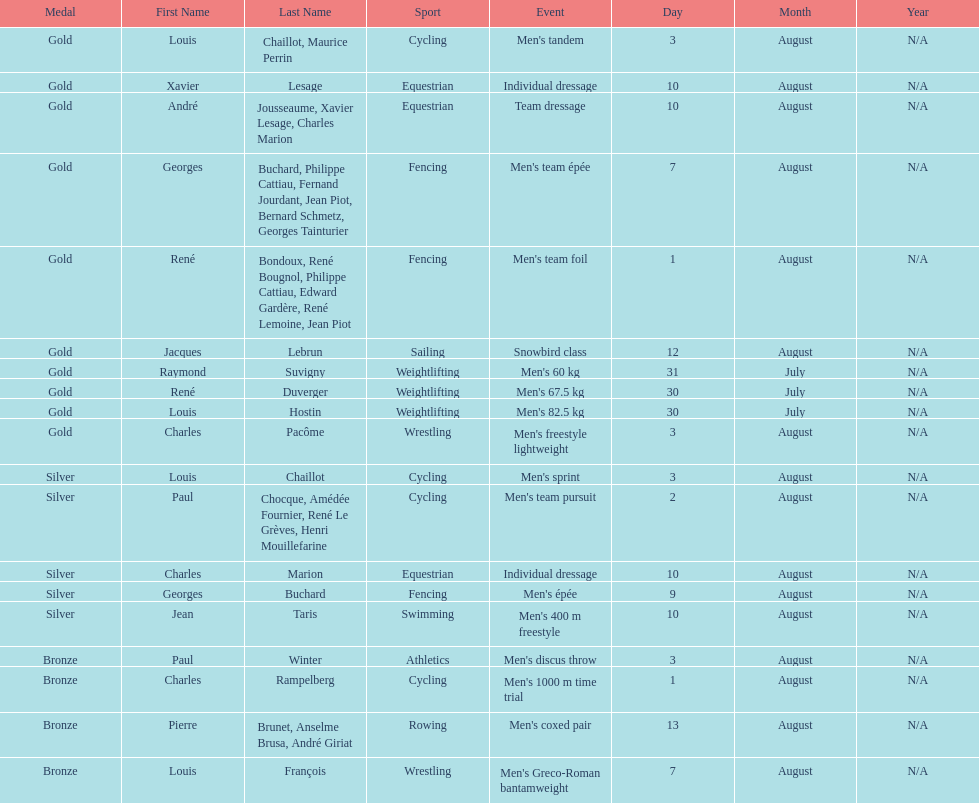What sport did louis challiot win the same medal as paul chocque in? Cycling. 